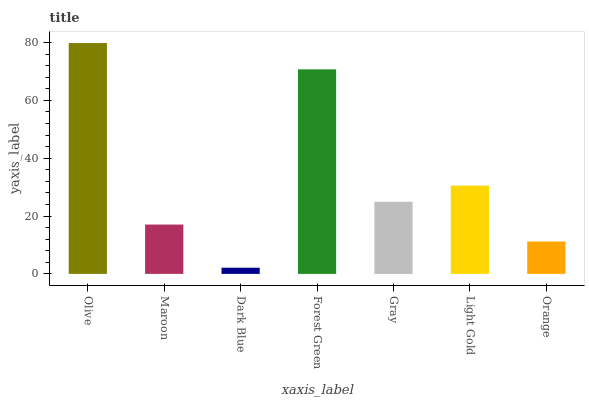Is Dark Blue the minimum?
Answer yes or no. Yes. Is Olive the maximum?
Answer yes or no. Yes. Is Maroon the minimum?
Answer yes or no. No. Is Maroon the maximum?
Answer yes or no. No. Is Olive greater than Maroon?
Answer yes or no. Yes. Is Maroon less than Olive?
Answer yes or no. Yes. Is Maroon greater than Olive?
Answer yes or no. No. Is Olive less than Maroon?
Answer yes or no. No. Is Gray the high median?
Answer yes or no. Yes. Is Gray the low median?
Answer yes or no. Yes. Is Olive the high median?
Answer yes or no. No. Is Dark Blue the low median?
Answer yes or no. No. 